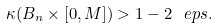<formula> <loc_0><loc_0><loc_500><loc_500>\kappa ( B _ { n } \times [ 0 , M ] ) > 1 - 2 \ e p s .</formula> 